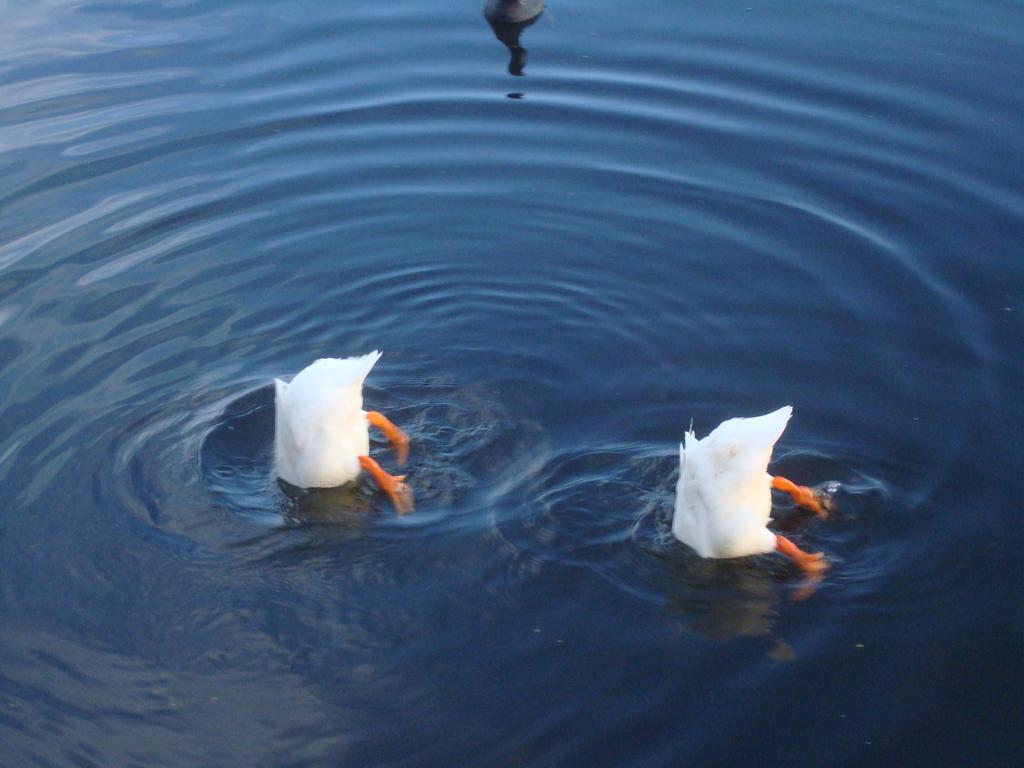Can you describe this image briefly? In the foreground of this picture, there are two white ducks in the water and a black colored duck on the top side of the image. 